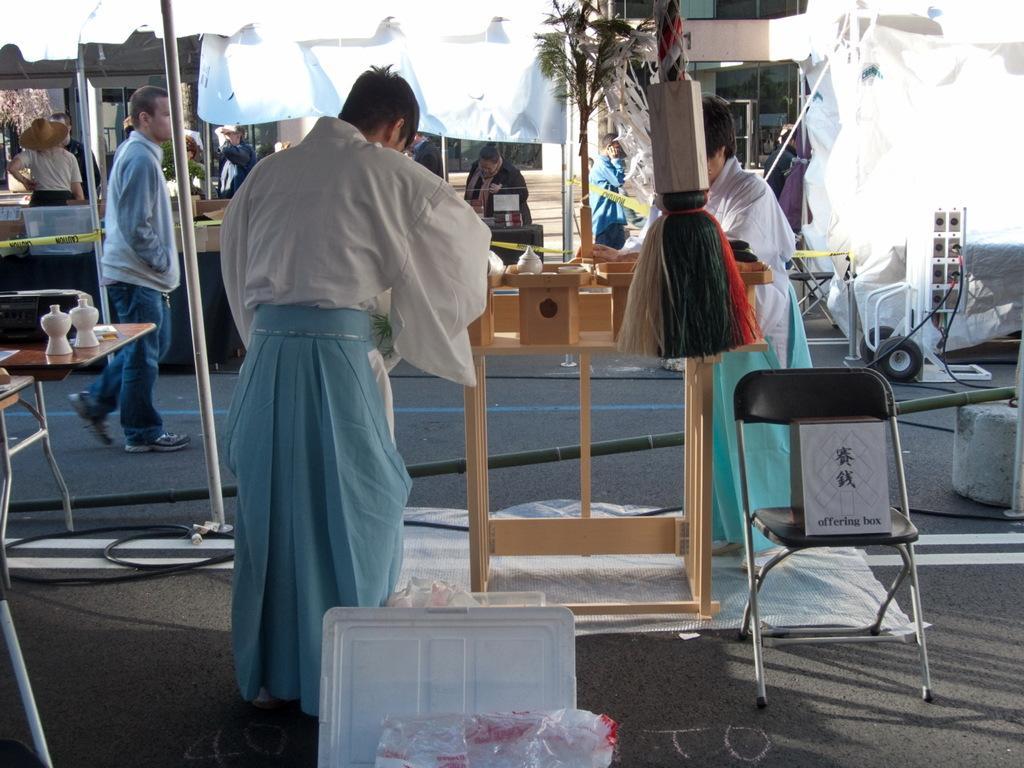How would you summarize this image in a sentence or two? In this picture we can see some people standing on the road. This is the chair and there is a table. Here we can see a pole and this is the plant. 